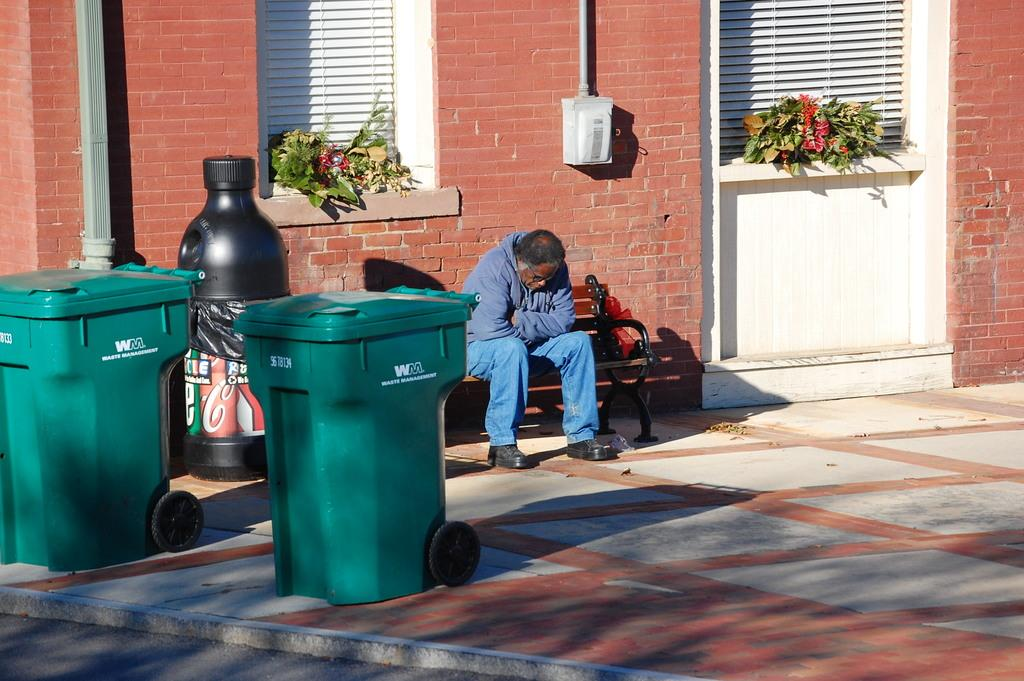<image>
Summarize the visual content of the image. A man sits hunched on a bench near two green cans with "Waste Management" on their sides. 